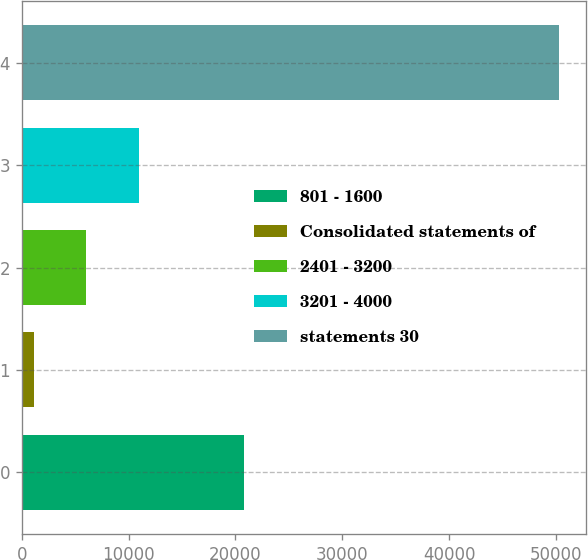<chart> <loc_0><loc_0><loc_500><loc_500><bar_chart><fcel>801 - 1600<fcel>Consolidated statements of<fcel>2401 - 3200<fcel>3201 - 4000<fcel>statements 30<nl><fcel>20801.6<fcel>1146<fcel>6059.9<fcel>10973.8<fcel>50285<nl></chart> 